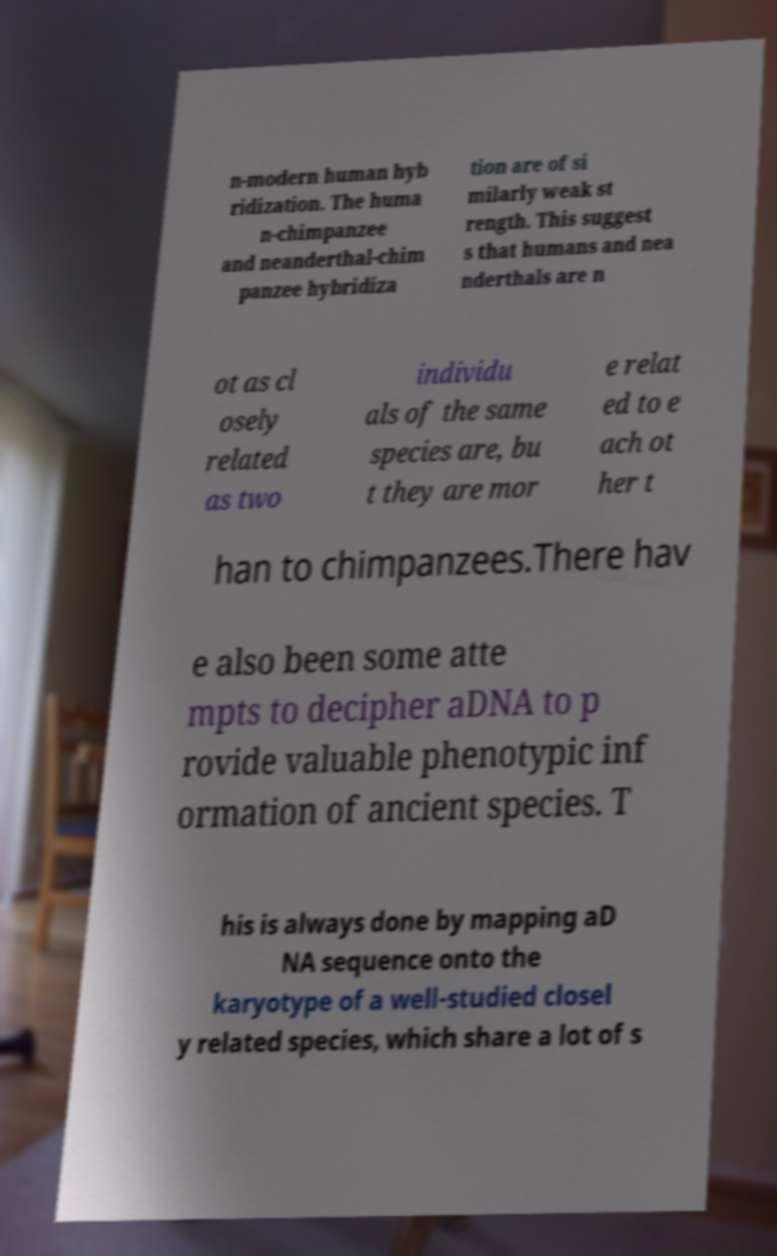Please read and relay the text visible in this image. What does it say? n-modern human hyb ridization. The huma n-chimpanzee and neanderthal-chim panzee hybridiza tion are of si milarly weak st rength. This suggest s that humans and nea nderthals are n ot as cl osely related as two individu als of the same species are, bu t they are mor e relat ed to e ach ot her t han to chimpanzees.There hav e also been some atte mpts to decipher aDNA to p rovide valuable phenotypic inf ormation of ancient species. T his is always done by mapping aD NA sequence onto the karyotype of a well-studied closel y related species, which share a lot of s 